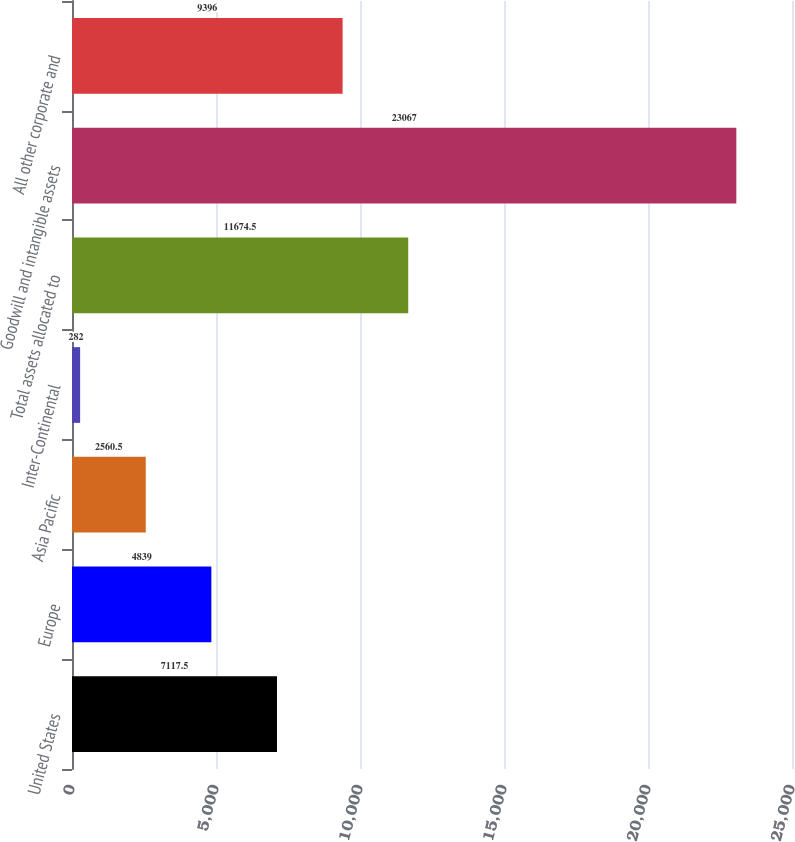Convert chart to OTSL. <chart><loc_0><loc_0><loc_500><loc_500><bar_chart><fcel>United States<fcel>Europe<fcel>Asia Pacific<fcel>Inter-Continental<fcel>Total assets allocated to<fcel>Goodwill and intangible assets<fcel>All other corporate and<nl><fcel>7117.5<fcel>4839<fcel>2560.5<fcel>282<fcel>11674.5<fcel>23067<fcel>9396<nl></chart> 